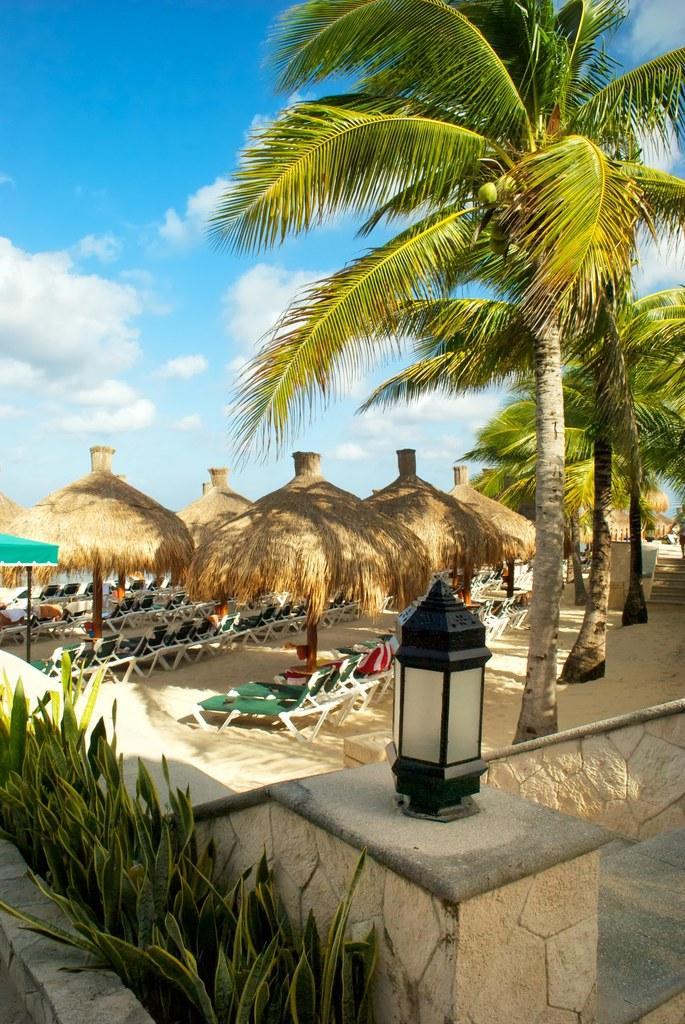Could you give a brief overview of what you see in this image? In the image in the center we can see trees,huts,lounge pool chairs,plants,wall,lamp,tent,sand etc. In the background we can see the sky and clouds. 